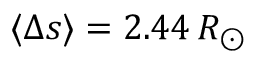<formula> <loc_0><loc_0><loc_500><loc_500>\langle \Delta s \rangle = 2 . 4 4 \, R _ { \odot }</formula> 